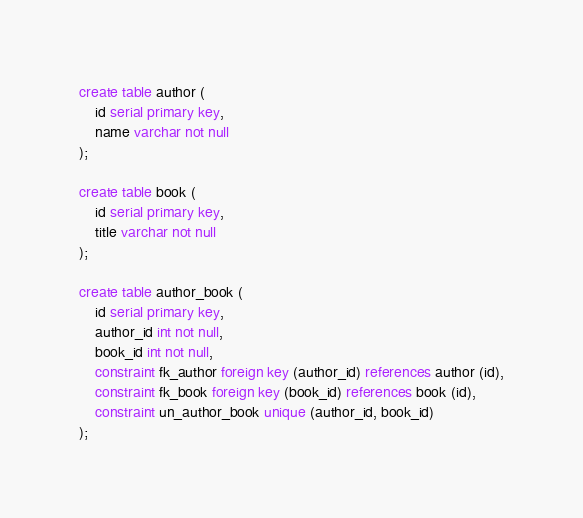<code> <loc_0><loc_0><loc_500><loc_500><_SQL_>create table author (
    id serial primary key,
    name varchar not null
);

create table book (
    id serial primary key,
    title varchar not null
);

create table author_book (
    id serial primary key,
    author_id int not null,
    book_id int not null,
    constraint fk_author foreign key (author_id) references author (id),
    constraint fk_book foreign key (book_id) references book (id),
    constraint un_author_book unique (author_id, book_id)
);</code> 